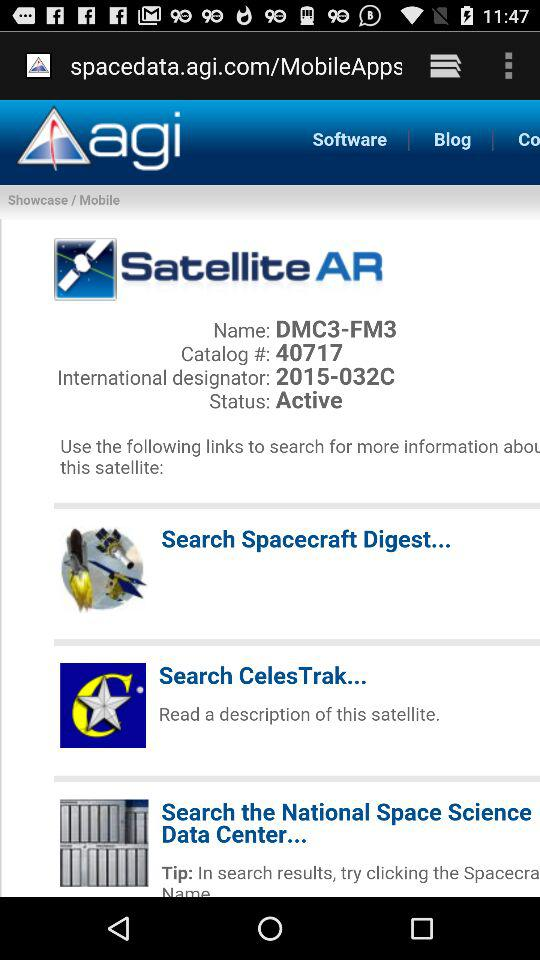What is the status of the satellite? The status of the satellite is "Active". 